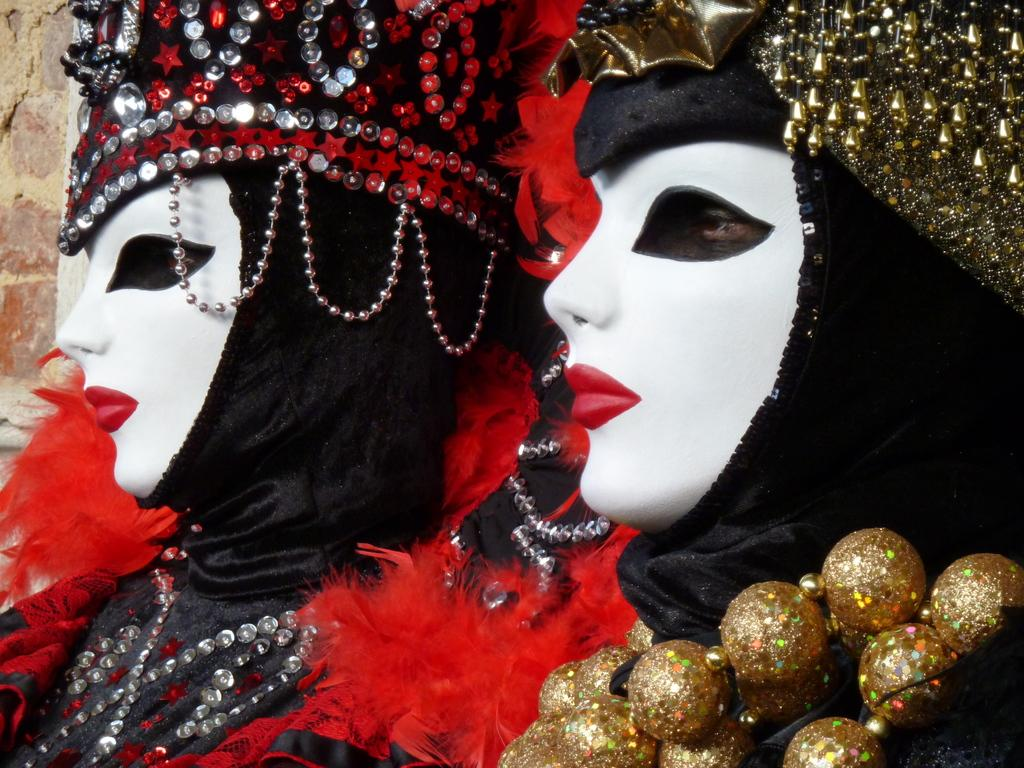Who or what is present in the image? There are people in the image. What are the people wearing on their faces? The people are wearing masks. What can be seen behind the people in the image? There is a wall in the background of the image. What type of skin condition can be seen on the people in the image? There is no indication of any skin condition on the people in the image, as they are wearing masks that cover their faces. 